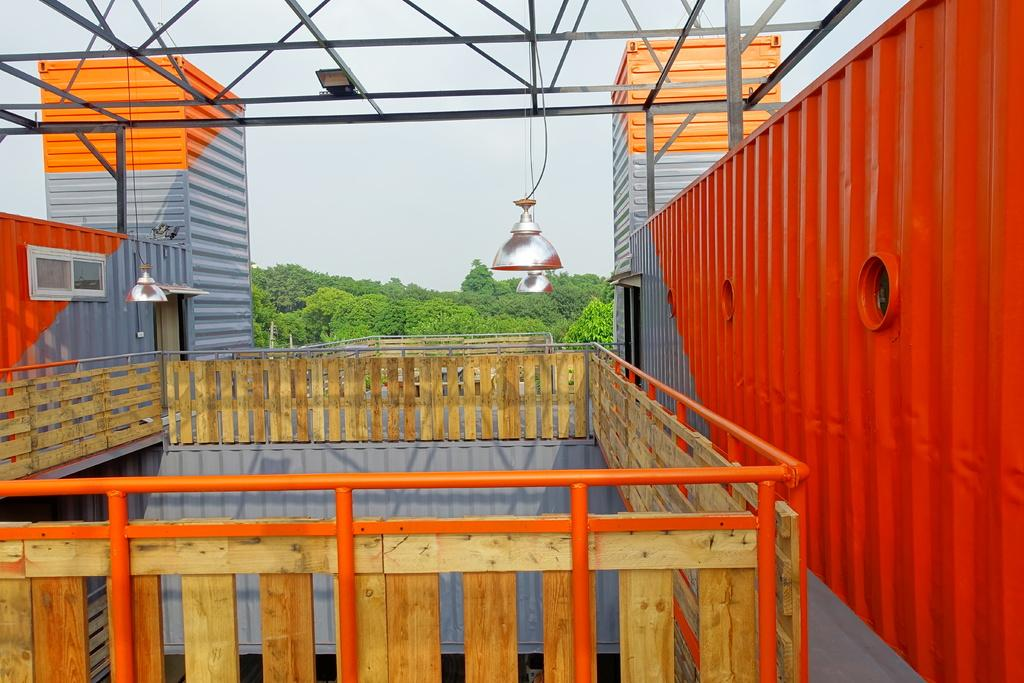What type of structures can be seen in the image? There are buildings in the image. What material is used for the rods visible in the image? The rods visible in the image are made of metal. What is hanging from the ceiling in the image? There are lights hanging in the image. What type of vegetation is present in the image? There are trees in the image. How would you describe the sky in the image? The sky is cloudy in the image. Can you tell me how many grains of rice are on the ground in the image? There is no reference to rice or grains in the image, so it is not possible to answer that question. What type of ball is being used by the laborer in the image? There is no laborer or ball present in the image. 